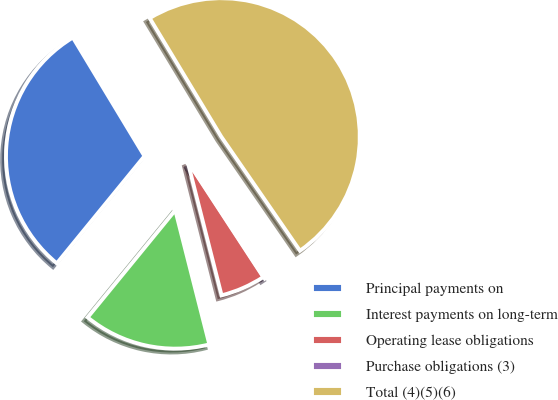Convert chart to OTSL. <chart><loc_0><loc_0><loc_500><loc_500><pie_chart><fcel>Principal payments on<fcel>Interest payments on long-term<fcel>Operating lease obligations<fcel>Purchase obligations (3)<fcel>Total (4)(5)(6)<nl><fcel>30.45%<fcel>14.86%<fcel>5.26%<fcel>0.4%<fcel>49.03%<nl></chart> 